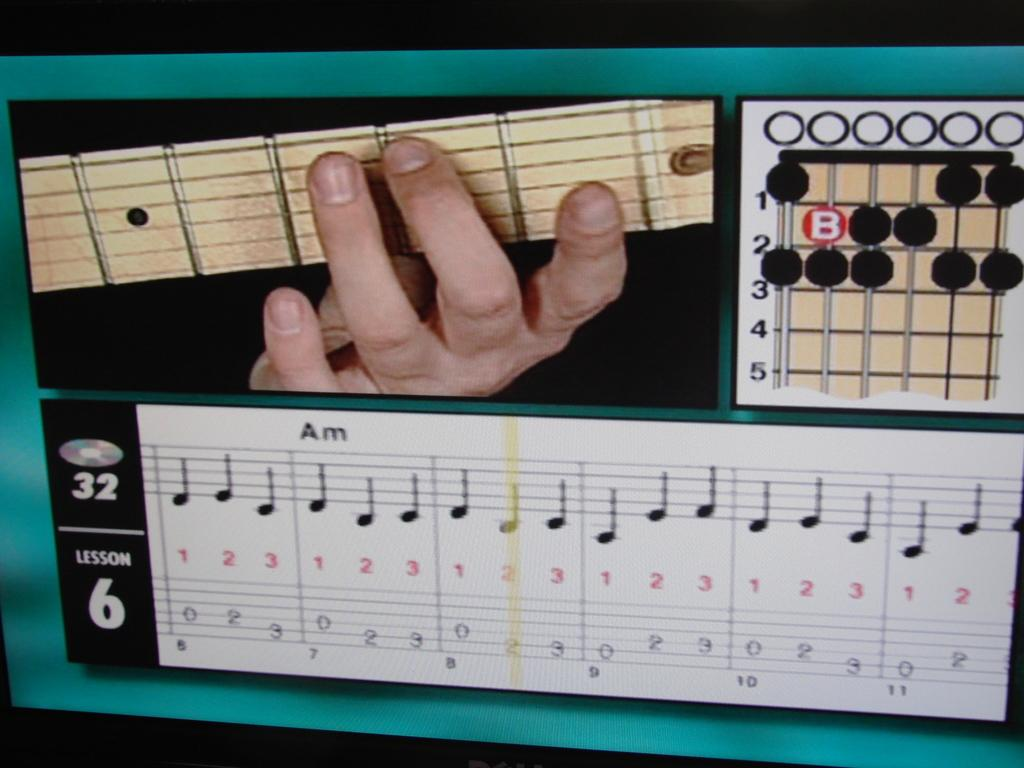What is the main object in the image? There is a screen in the image. What part of a person can be seen in the image? A person's hand is visible in the image. What type of content is displayed on the screen? There is text and numbers in the image. Are there any symbols or icons related to music in the image? Yes, there are musical notes in the image. How many bridges can be seen crossing the river in the image? There is no river or bridge present in the image; it features a screen with text, numbers, and musical notes. What type of neck accessory is the person wearing in the image? There is no person wearing any neck accessory in the image, as only a hand is visible. 